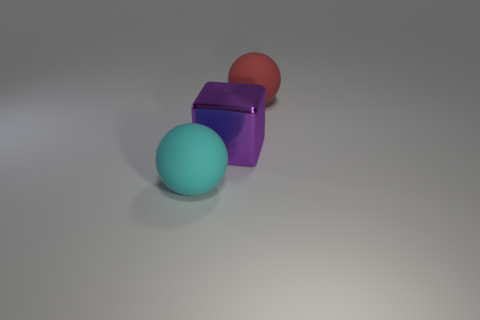Subtract all cubes. How many objects are left? 2 Add 3 tiny brown objects. How many objects exist? 6 Add 3 cyan matte objects. How many cyan matte objects exist? 4 Subtract 0 yellow blocks. How many objects are left? 3 Subtract all yellow balls. Subtract all gray cylinders. How many balls are left? 2 Subtract all red blocks. How many cyan balls are left? 1 Subtract all large red matte cylinders. Subtract all rubber balls. How many objects are left? 1 Add 1 red things. How many red things are left? 2 